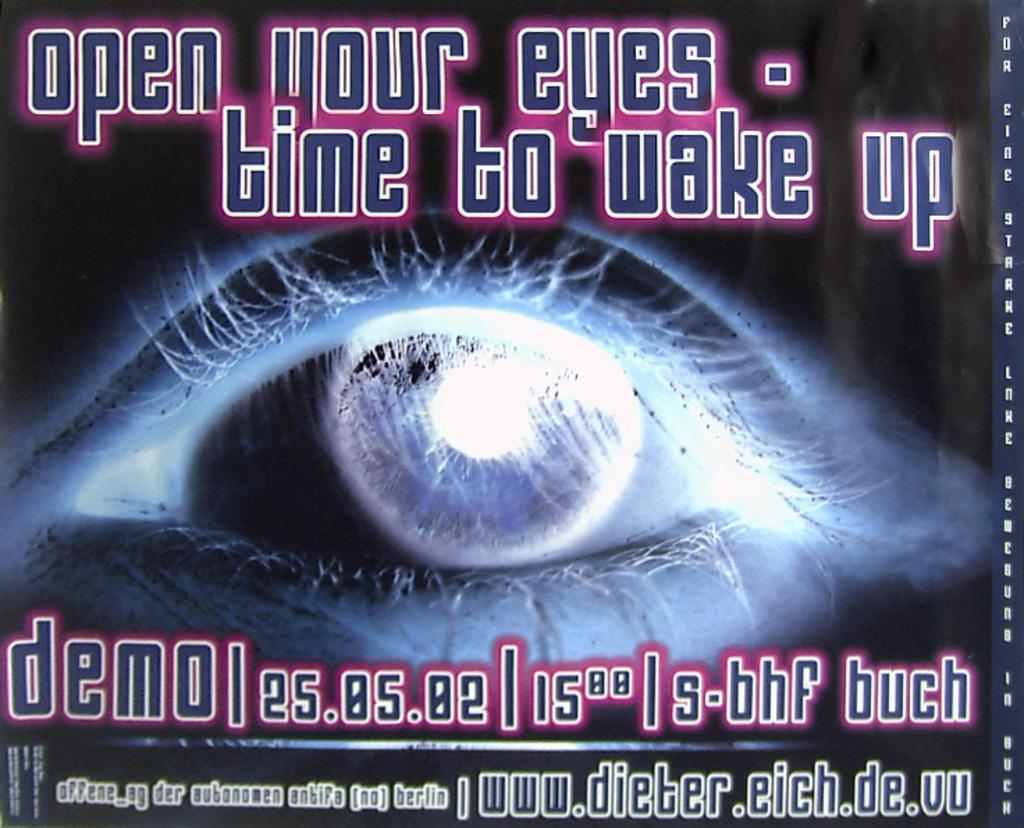<image>
Provide a brief description of the given image. Poster that says the demo will be on the 25th. 